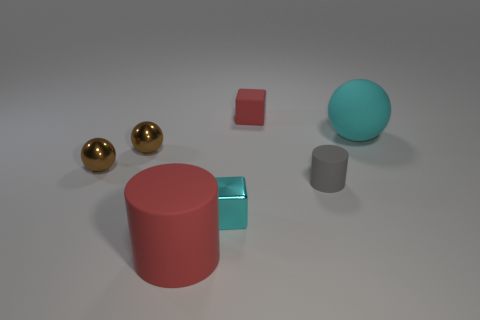Add 3 large red things. How many objects exist? 10 Subtract 1 balls. How many balls are left? 2 Subtract all spheres. How many objects are left? 4 Subtract all yellow metallic spheres. Subtract all rubber blocks. How many objects are left? 6 Add 2 rubber things. How many rubber things are left? 6 Add 4 small purple matte objects. How many small purple matte objects exist? 4 Subtract 0 yellow cylinders. How many objects are left? 7 